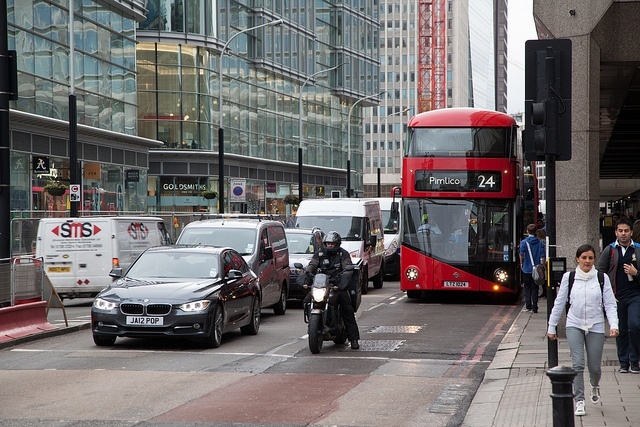Describe the objects in this image and their specific colors. I can see bus in black, gray, brown, and darkgray tones, car in black, lightgray, gray, and darkgray tones, traffic light in black, gray, purple, and lightgray tones, truck in black, lightgray, darkgray, and gray tones, and people in black, lightgray, gray, and darkgray tones in this image. 